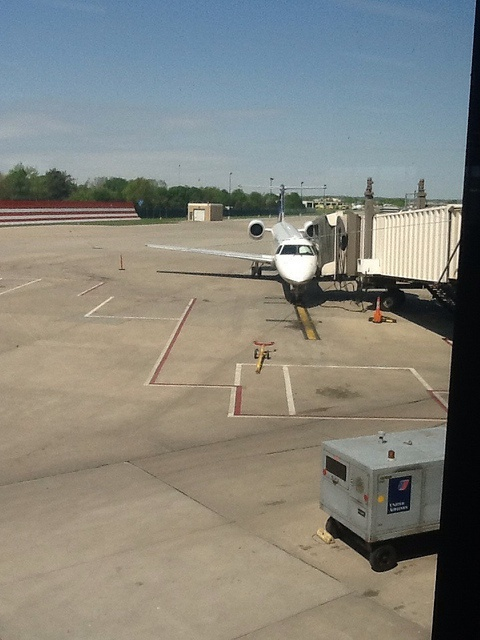Describe the objects in this image and their specific colors. I can see a airplane in gray, white, darkgray, and black tones in this image. 